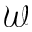<formula> <loc_0><loc_0><loc_500><loc_500>\mathcal { W }</formula> 